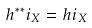Convert formula to latex. <formula><loc_0><loc_0><loc_500><loc_500>h ^ { \ast \ast } i _ { X } = h i _ { X }</formula> 